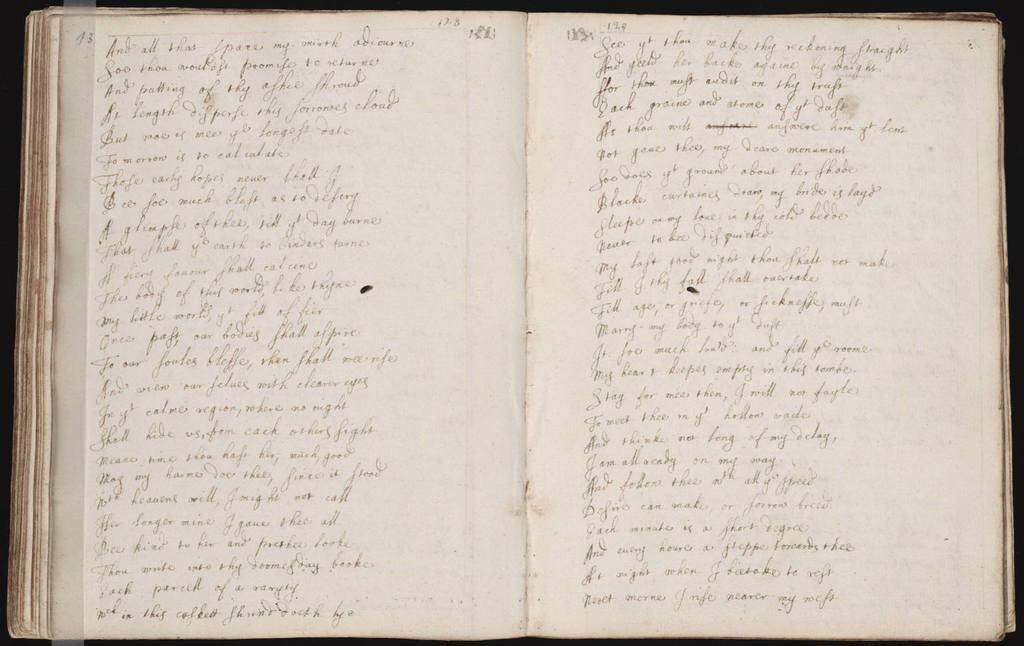<image>
Give a short and clear explanation of the subsequent image. The book is opened to page 13 displayed at the top left corner. 